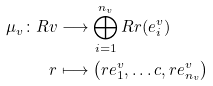Convert formula to latex. <formula><loc_0><loc_0><loc_500><loc_500>\mu _ { v } \colon R v & \longrightarrow \bigoplus _ { i = 1 } ^ { n _ { v } } R r ( e ^ { v } _ { i } ) \\ r & \longmapsto \left ( r e ^ { v } _ { 1 } , \dots c , r e ^ { v } _ { n _ { v } } \right )</formula> 